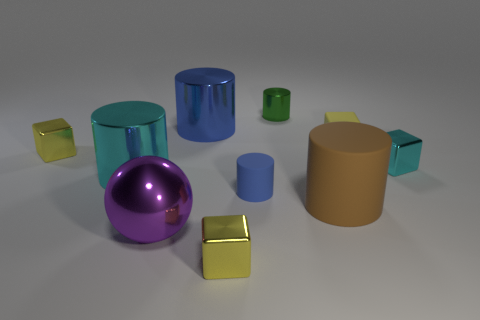Considering the colors present, which two objects seem most alike in color? The two objects most alike in color are the large and small cylinders, both sharing a similar hue of blue.  What might be the purpose of this arrangement of objects? This arrangement of objects could serve several purposes such as a visual study of shapes, materials, and shadows, or it might be an artistic composition focusing on color contrasts and object placement. 